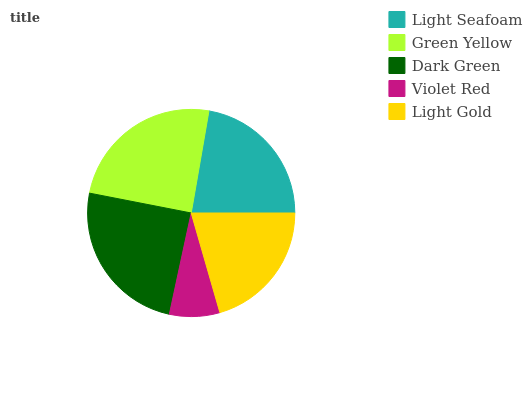Is Violet Red the minimum?
Answer yes or no. Yes. Is Dark Green the maximum?
Answer yes or no. Yes. Is Green Yellow the minimum?
Answer yes or no. No. Is Green Yellow the maximum?
Answer yes or no. No. Is Green Yellow greater than Light Seafoam?
Answer yes or no. Yes. Is Light Seafoam less than Green Yellow?
Answer yes or no. Yes. Is Light Seafoam greater than Green Yellow?
Answer yes or no. No. Is Green Yellow less than Light Seafoam?
Answer yes or no. No. Is Light Seafoam the high median?
Answer yes or no. Yes. Is Light Seafoam the low median?
Answer yes or no. Yes. Is Violet Red the high median?
Answer yes or no. No. Is Green Yellow the low median?
Answer yes or no. No. 